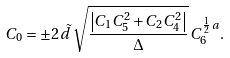Convert formula to latex. <formula><loc_0><loc_0><loc_500><loc_500>C _ { 0 } = \pm 2 \, \tilde { d } \, \sqrt { \frac { \left | C _ { 1 } C _ { 5 } ^ { 2 } + C _ { 2 } C _ { 4 } ^ { 2 } \right | } { \Delta } } \, C _ { 6 } ^ { \frac { 1 } { 2 } \, a } .</formula> 